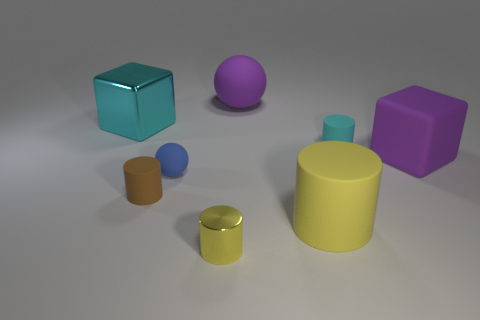Subtract all yellow metallic cylinders. How many cylinders are left? 3 Subtract 3 cylinders. How many cylinders are left? 1 Subtract all brown cylinders. How many cylinders are left? 3 Add 1 big cyan shiny things. How many objects exist? 9 Subtract all balls. How many objects are left? 6 Subtract all yellow balls. How many cyan cylinders are left? 1 Subtract all cyan cubes. Subtract all balls. How many objects are left? 5 Add 4 tiny things. How many tiny things are left? 8 Add 5 metal objects. How many metal objects exist? 7 Subtract 0 red spheres. How many objects are left? 8 